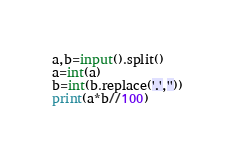<code> <loc_0><loc_0><loc_500><loc_500><_Cython_>a,b=input().split()
a=int(a)
b=int(b.replace('.',''))
print(a*b//100)</code> 